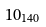Convert formula to latex. <formula><loc_0><loc_0><loc_500><loc_500>1 0 _ { 1 4 0 }</formula> 